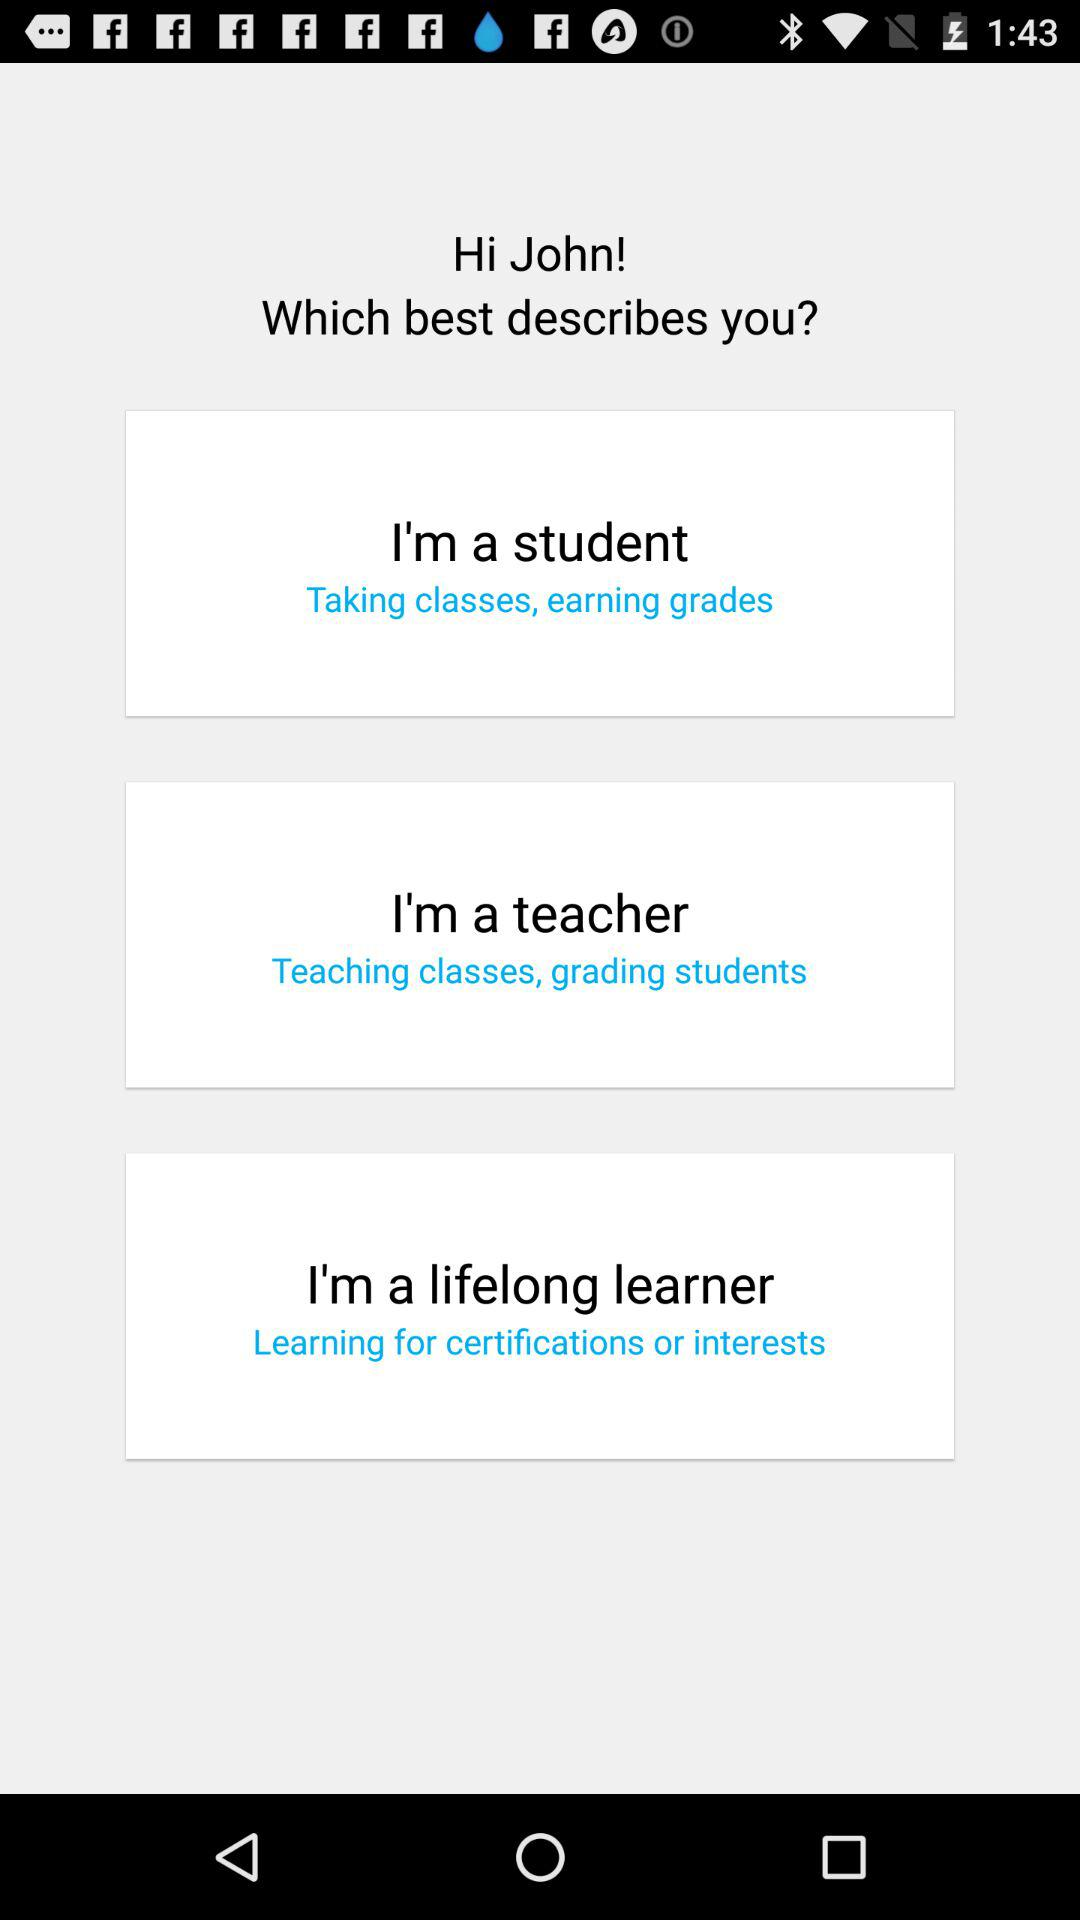What is the name of the user? The name of the user is John. 